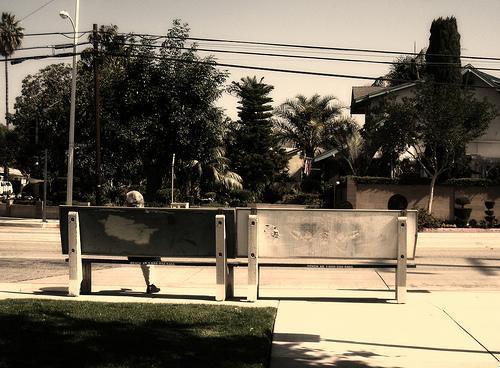How many benches are there?
Give a very brief answer. 2. How many bench on sidewalk?
Give a very brief answer. 1. How many backs are there?
Give a very brief answer. 2. 